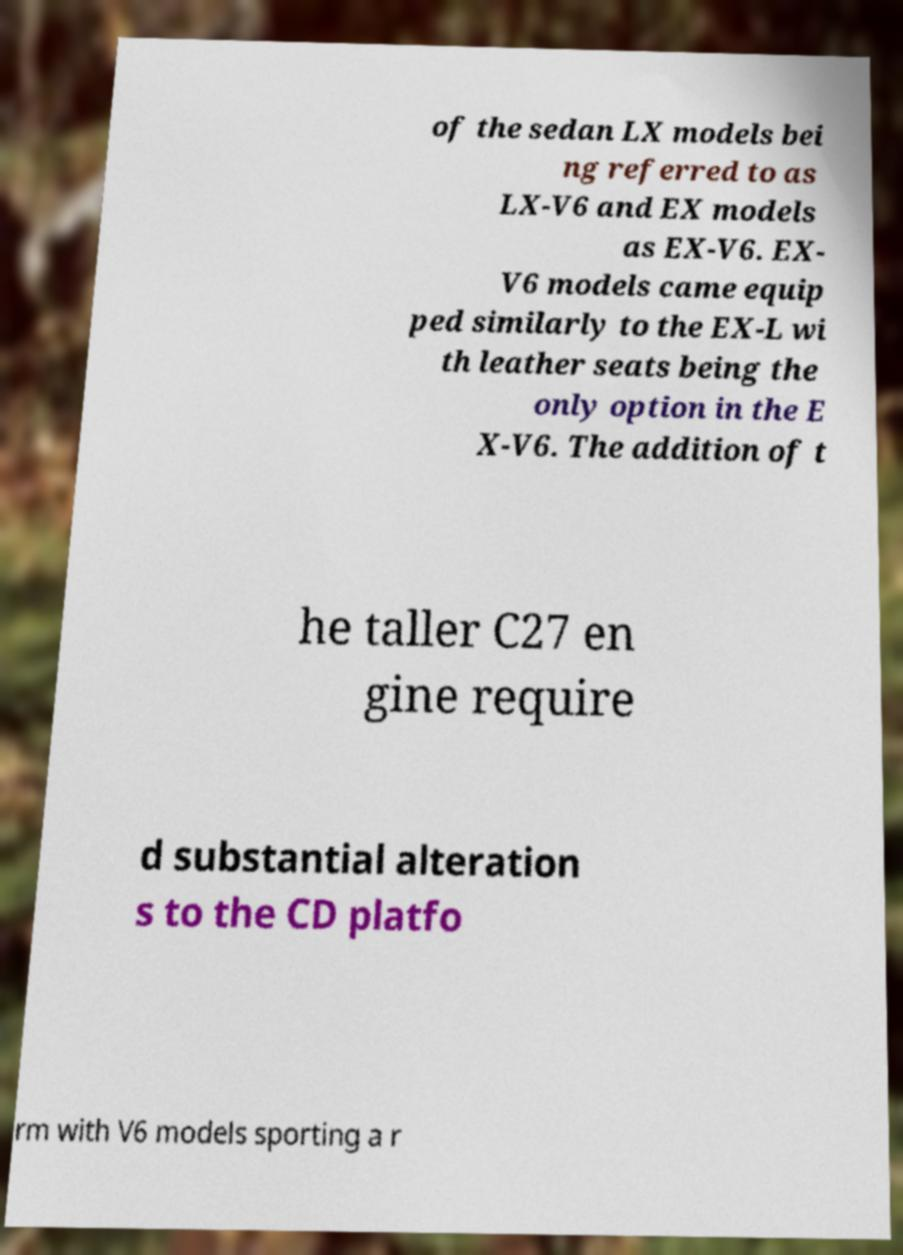What messages or text are displayed in this image? I need them in a readable, typed format. of the sedan LX models bei ng referred to as LX-V6 and EX models as EX-V6. EX- V6 models came equip ped similarly to the EX-L wi th leather seats being the only option in the E X-V6. The addition of t he taller C27 en gine require d substantial alteration s to the CD platfo rm with V6 models sporting a r 